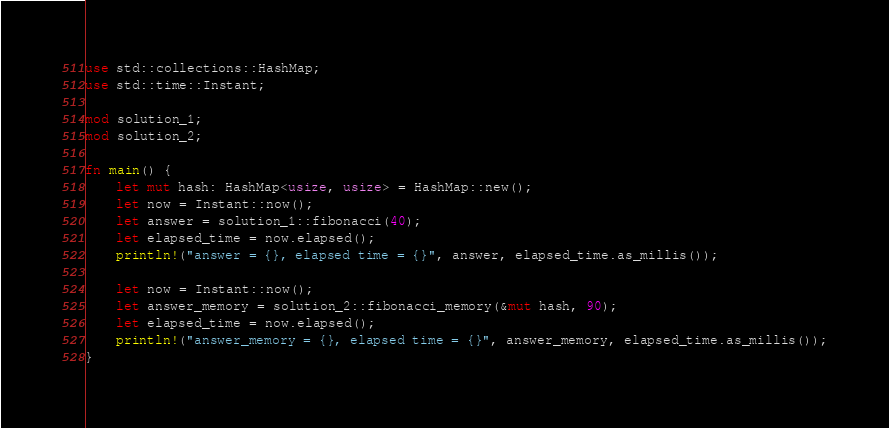<code> <loc_0><loc_0><loc_500><loc_500><_Rust_>use std::collections::HashMap;
use std::time::Instant;

mod solution_1;
mod solution_2;

fn main() {
    let mut hash: HashMap<usize, usize> = HashMap::new();
    let now = Instant::now();
    let answer = solution_1::fibonacci(40);
    let elapsed_time = now.elapsed();
    println!("answer = {}, elapsed time = {}", answer, elapsed_time.as_millis());
    
    let now = Instant::now();
    let answer_memory = solution_2::fibonacci_memory(&mut hash, 90);
    let elapsed_time = now.elapsed();
    println!("answer_memory = {}, elapsed time = {}", answer_memory, elapsed_time.as_millis());
}
</code> 